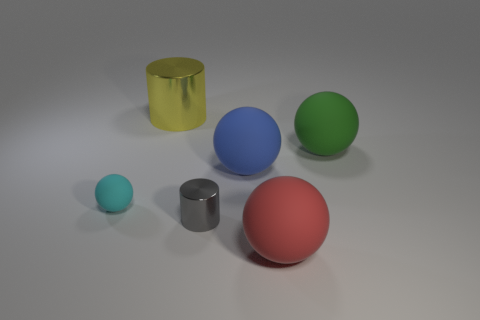How many things are either green spheres or metal things that are in front of the cyan sphere?
Provide a short and direct response. 2. There is a thing that is left of the red ball and in front of the tiny cyan sphere; what color is it?
Offer a terse response. Gray. Do the yellow metal object and the cyan sphere have the same size?
Your answer should be compact. No. The object in front of the gray cylinder is what color?
Your answer should be compact. Red. Is there a tiny object that has the same color as the large metallic object?
Offer a terse response. No. The ball that is the same size as the gray shiny cylinder is what color?
Your response must be concise. Cyan. Is the gray object the same shape as the red object?
Your answer should be compact. No. What is the thing that is behind the big green rubber object made of?
Ensure brevity in your answer.  Metal. The small rubber thing is what color?
Offer a very short reply. Cyan. Do the shiny object that is behind the gray shiny thing and the ball behind the blue rubber sphere have the same size?
Make the answer very short. Yes. 